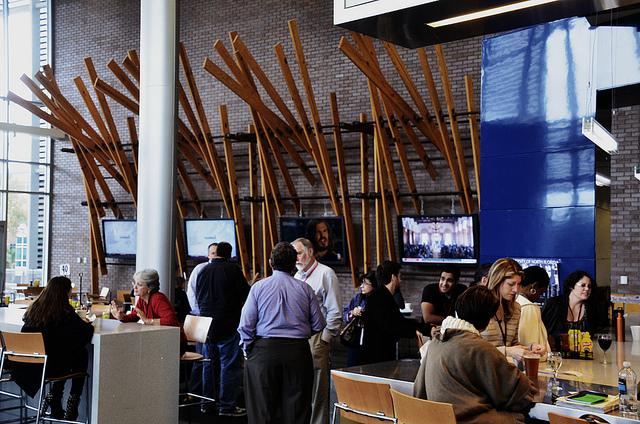What color is the wall?
Concise answer only. Blue. What does the name say on the blocks of wood?
Be succinct. Nothing. Are they enjoying themselves?
Keep it brief. Yes. Does it seem that some people are colder than others here?
Give a very brief answer. Yes. Are these people eating indoors?
Be succinct. Yes. How many bald men in this photo?
Keep it brief. 0. 